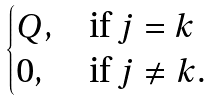Convert formula to latex. <formula><loc_0><loc_0><loc_500><loc_500>\begin{cases} Q , & \text {if $j=k$} \\ 0 , & \text {if $j\neq k.$} \end{cases}</formula> 